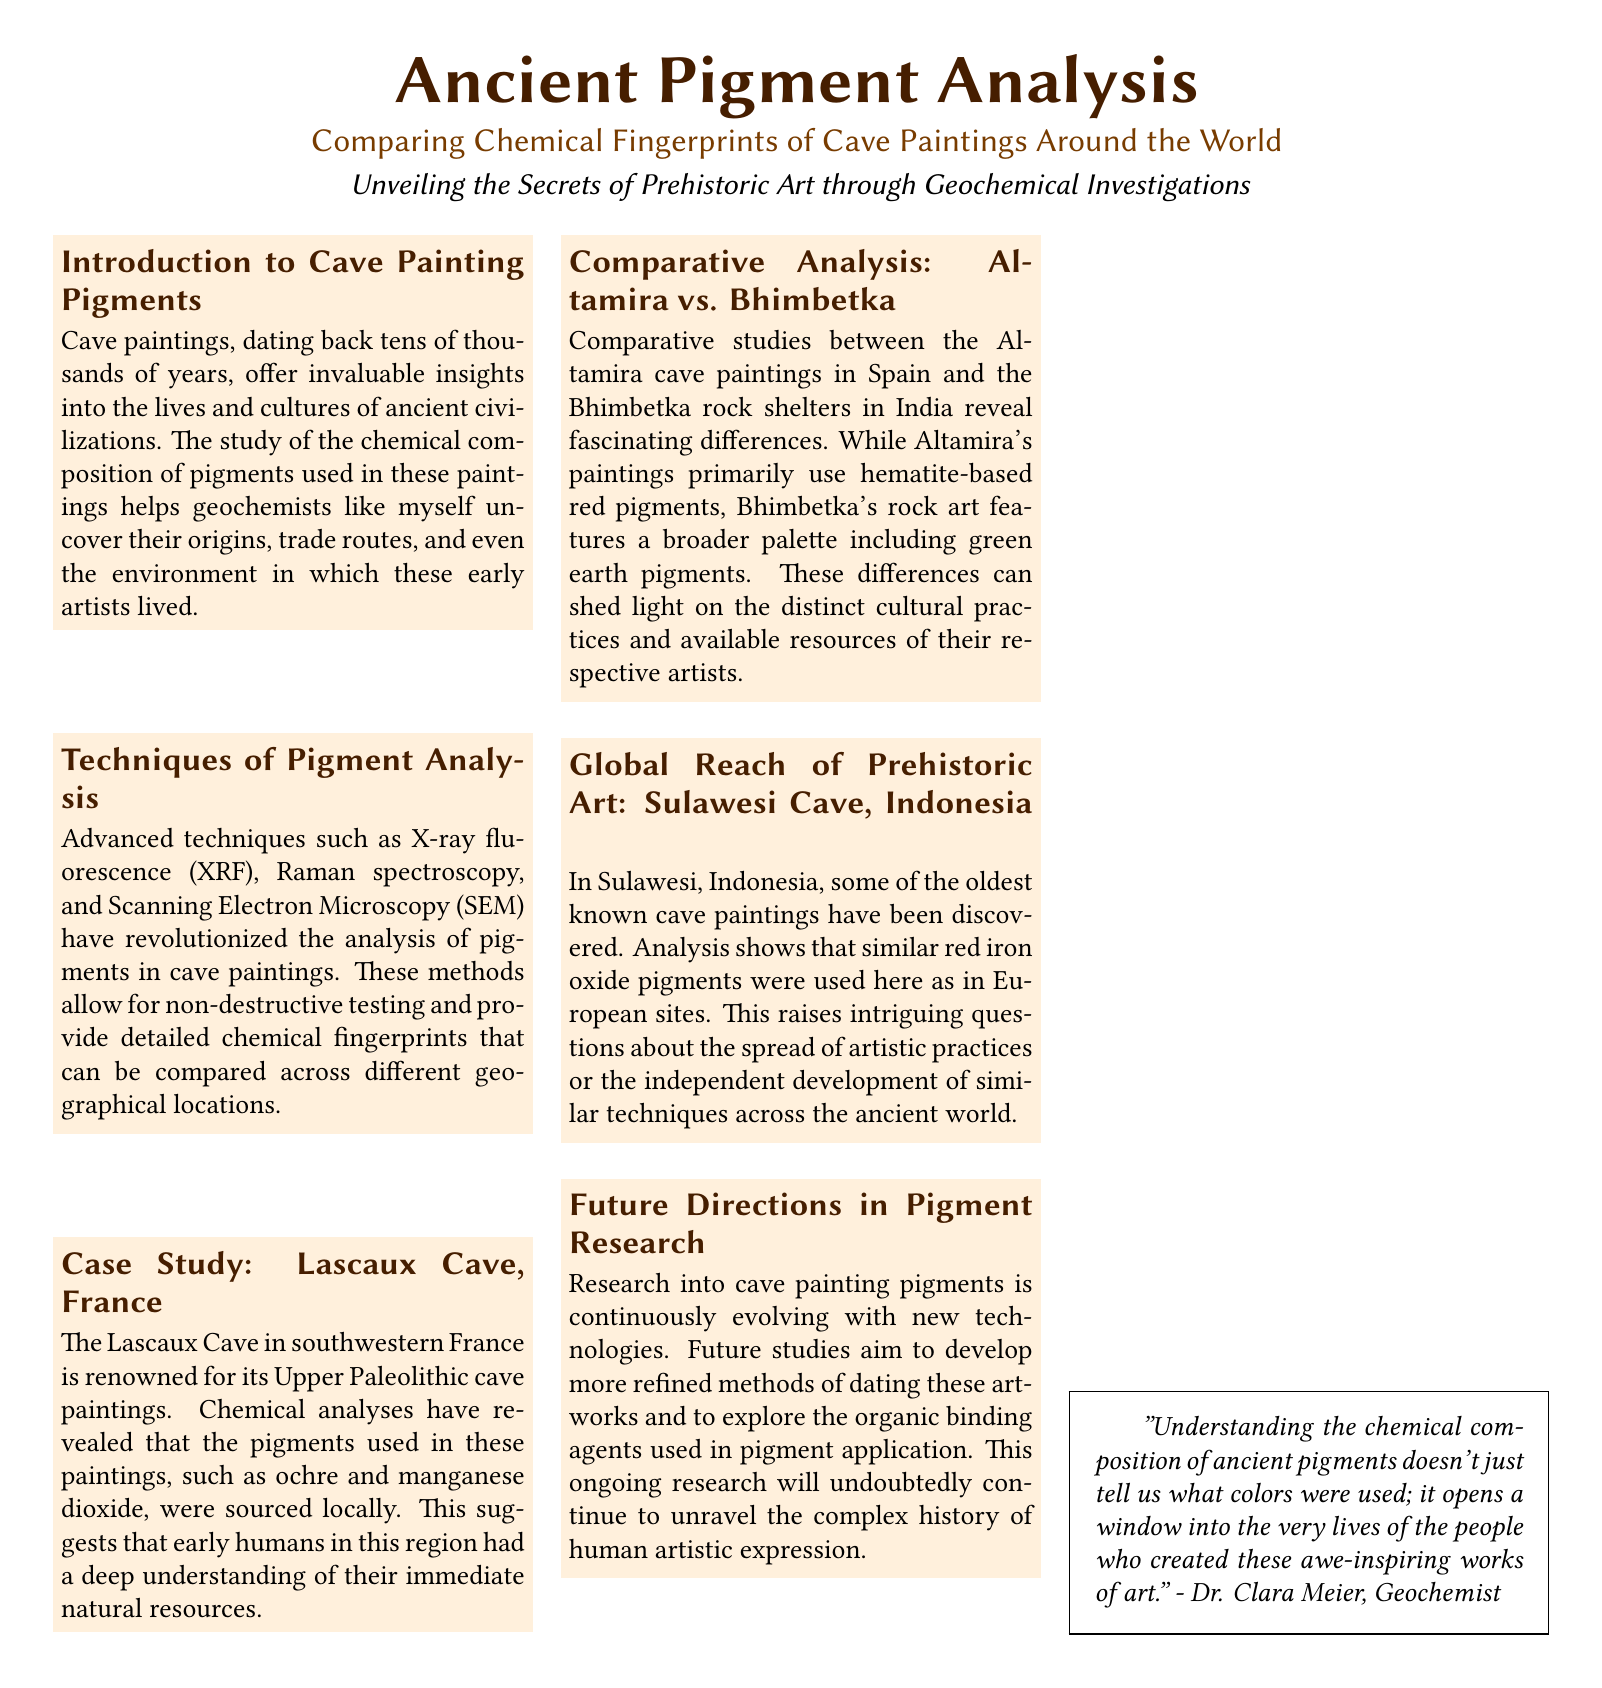What is the primary focus of the document? The document focuses on analyzing the chemical composition of cave paintings to uncover their origins.
Answer: Ancient Pigment Analysis Which cave is known for its Upper Paleolithic paintings? The document mentions the Lascaux Cave in southwestern France.
Answer: Lascaux Cave What advanced technique allows for non-destructive testing of pigments? The document states that advanced techniques like X-ray fluorescence (XRF) are used for non-destructive testing.
Answer: X-ray fluorescence (XRF) Which pigments are primarily used in Altamira's cave paintings? The document indicates that Altamira's paintings primarily use hematite-based red pigments.
Answer: Hematite-based red pigments What do the findings in Sulawesi, Indonesia, suggest about ancient artistic practices? The document raises questions about the spread of artistic practices or independent development of techniques.
Answer: Spread of artistic practices Who is quoted in the document discussing understanding ancient pigments? The document quotes Dr. Clara Meier, a geochemist.
Answer: Dr. Clara Meier What does the analysis of Bhimbetka rock art reveal? The rock art features a broader palette including green earth pigments.
Answer: Broader palette including green earth pigments What is the aim of future studies in pigment research? The document mentions that future studies aim to develop more refined methods of dating artworks.
Answer: Develop more refined methods of dating artworks 